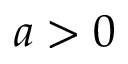<formula> <loc_0><loc_0><loc_500><loc_500>a > 0</formula> 